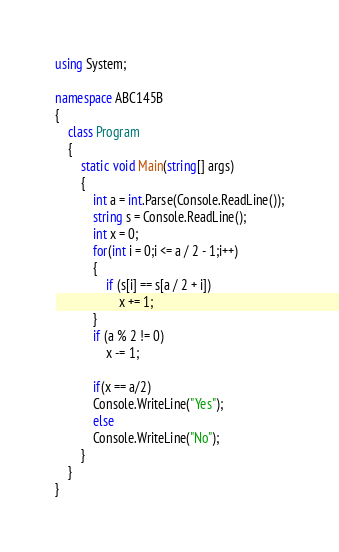Convert code to text. <code><loc_0><loc_0><loc_500><loc_500><_C#_>using System;

namespace ABC145B
{
    class Program
    {
        static void Main(string[] args)
        {
            int a = int.Parse(Console.ReadLine());
            string s = Console.ReadLine();
            int x = 0;
            for(int i = 0;i <= a / 2 - 1;i++)
            {
                if (s[i] == s[a / 2 + i])
                    x += 1;
            }
            if (a % 2 != 0)
                x -= 1;

            if(x == a/2)
            Console.WriteLine("Yes");
            else
            Console.WriteLine("No");
        }
    }
}</code> 